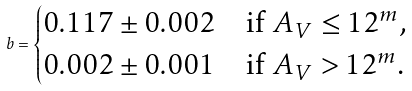<formula> <loc_0><loc_0><loc_500><loc_500>b = \begin{cases} 0 . 1 1 7 \pm 0 . 0 0 2 & \text {if $A_{V} \leq 12^{m}$,} \\ 0 . 0 0 2 \pm 0 . 0 0 1 & \text {if $A_{V} > 12^{m}$.} \end{cases}</formula> 